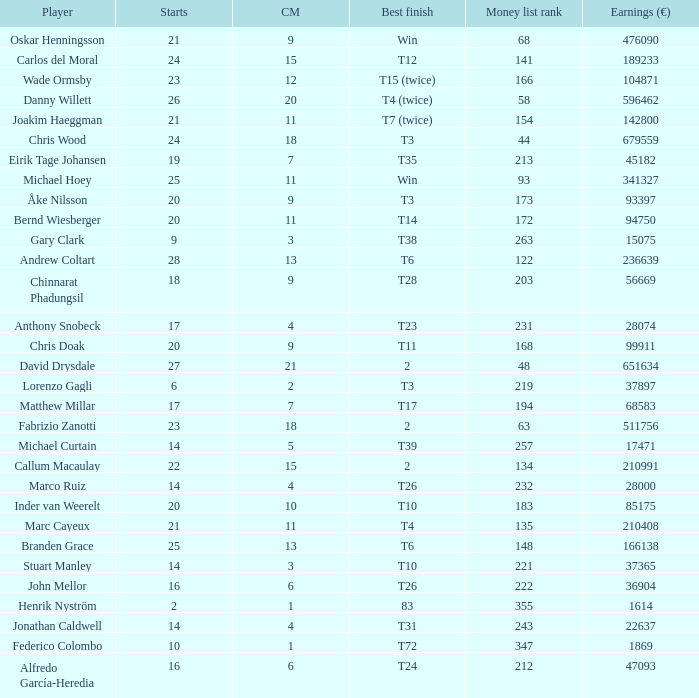Which player made exactly 26 starts? Danny Willett. 